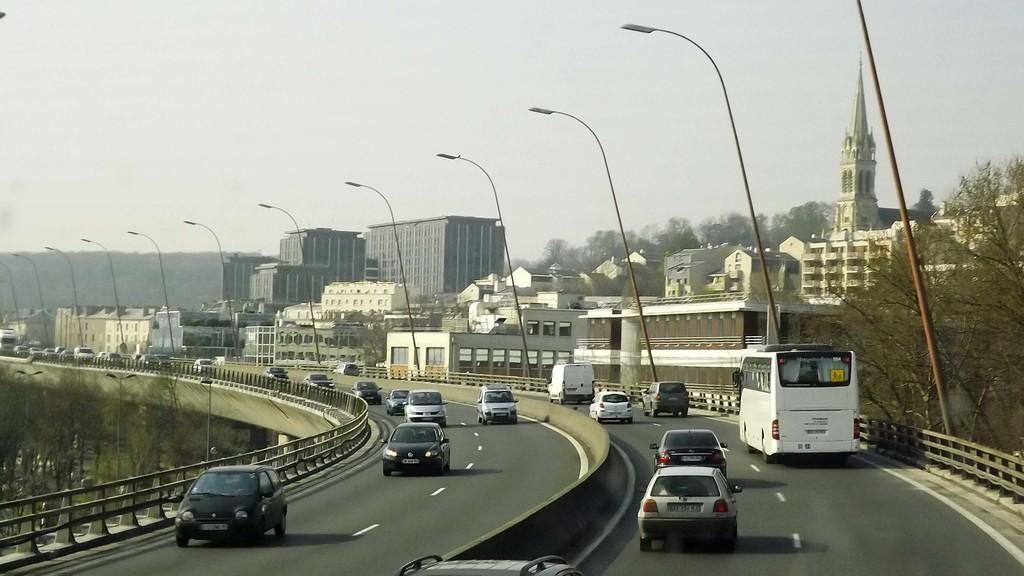How would you summarize this image in a sentence or two? This is the picture city. In this image there are vehicles on the road and there is a railing on both sides of the road. At the back there are buildings, trees and poles. At the top there is sky. At the bottom there is a road and there is grass. 